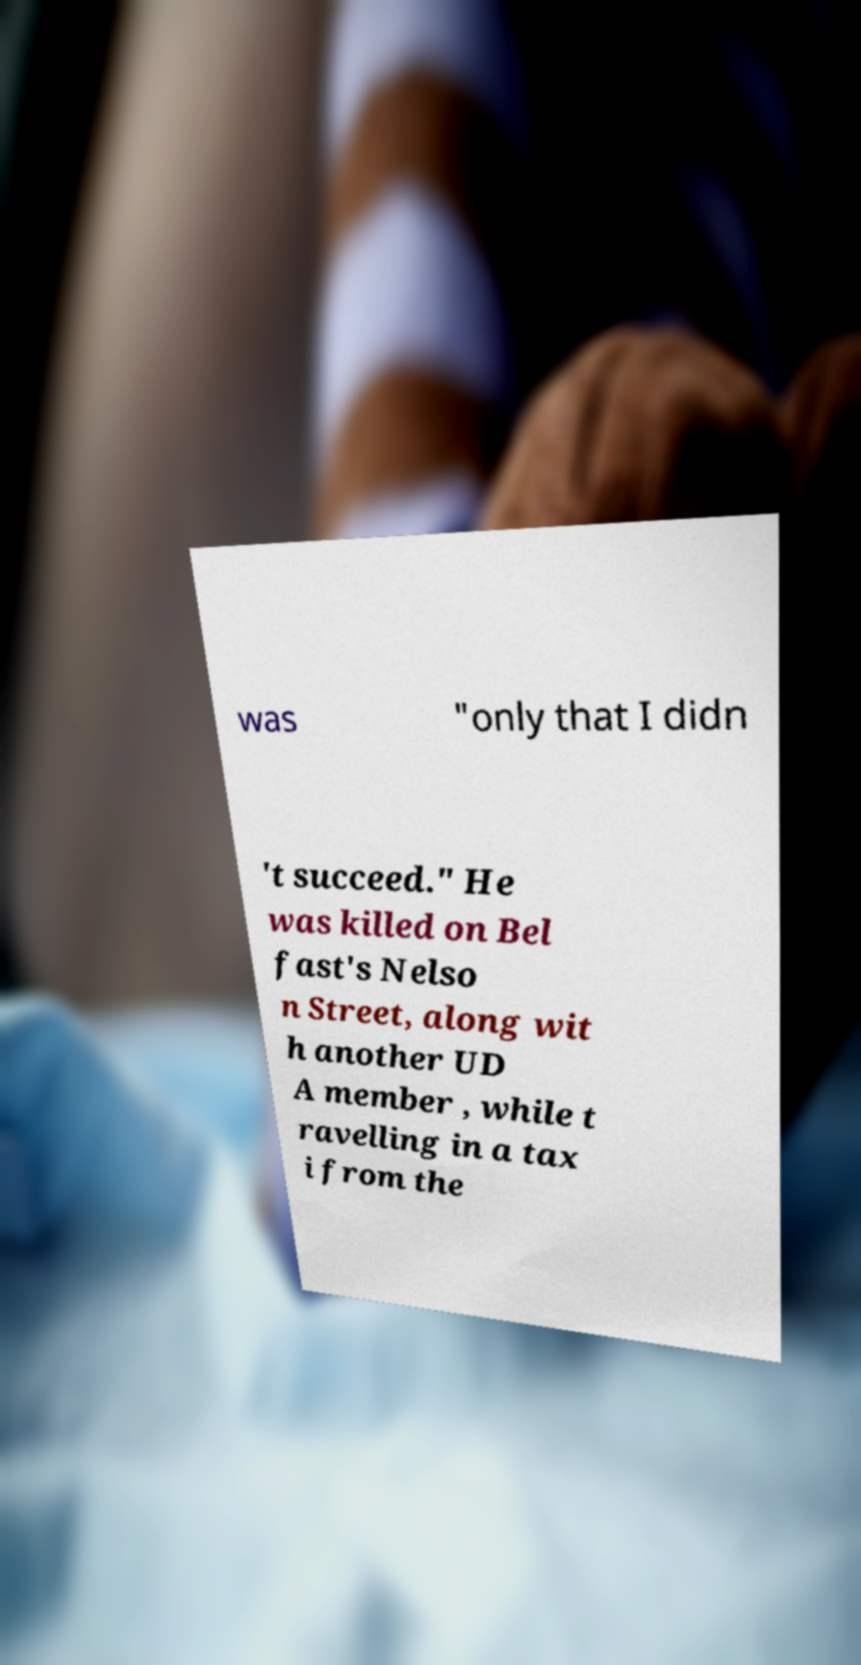What messages or text are displayed in this image? I need them in a readable, typed format. was "only that I didn 't succeed." He was killed on Bel fast's Nelso n Street, along wit h another UD A member , while t ravelling in a tax i from the 